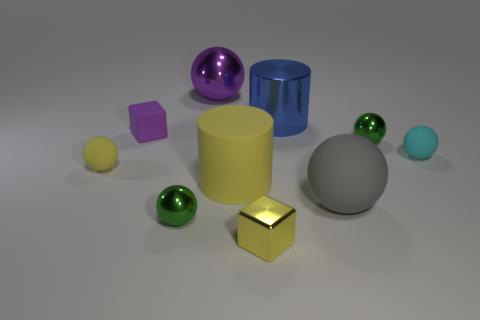Subtract 3 spheres. How many spheres are left? 3 Subtract all big metallic balls. How many balls are left? 5 Subtract all yellow balls. How many balls are left? 5 Subtract all red balls. Subtract all brown cubes. How many balls are left? 6 Subtract all cylinders. How many objects are left? 8 Add 2 red matte blocks. How many red matte blocks exist? 2 Subtract 1 blue cylinders. How many objects are left? 9 Subtract all yellow things. Subtract all tiny yellow shiny cubes. How many objects are left? 6 Add 8 purple rubber objects. How many purple rubber objects are left? 9 